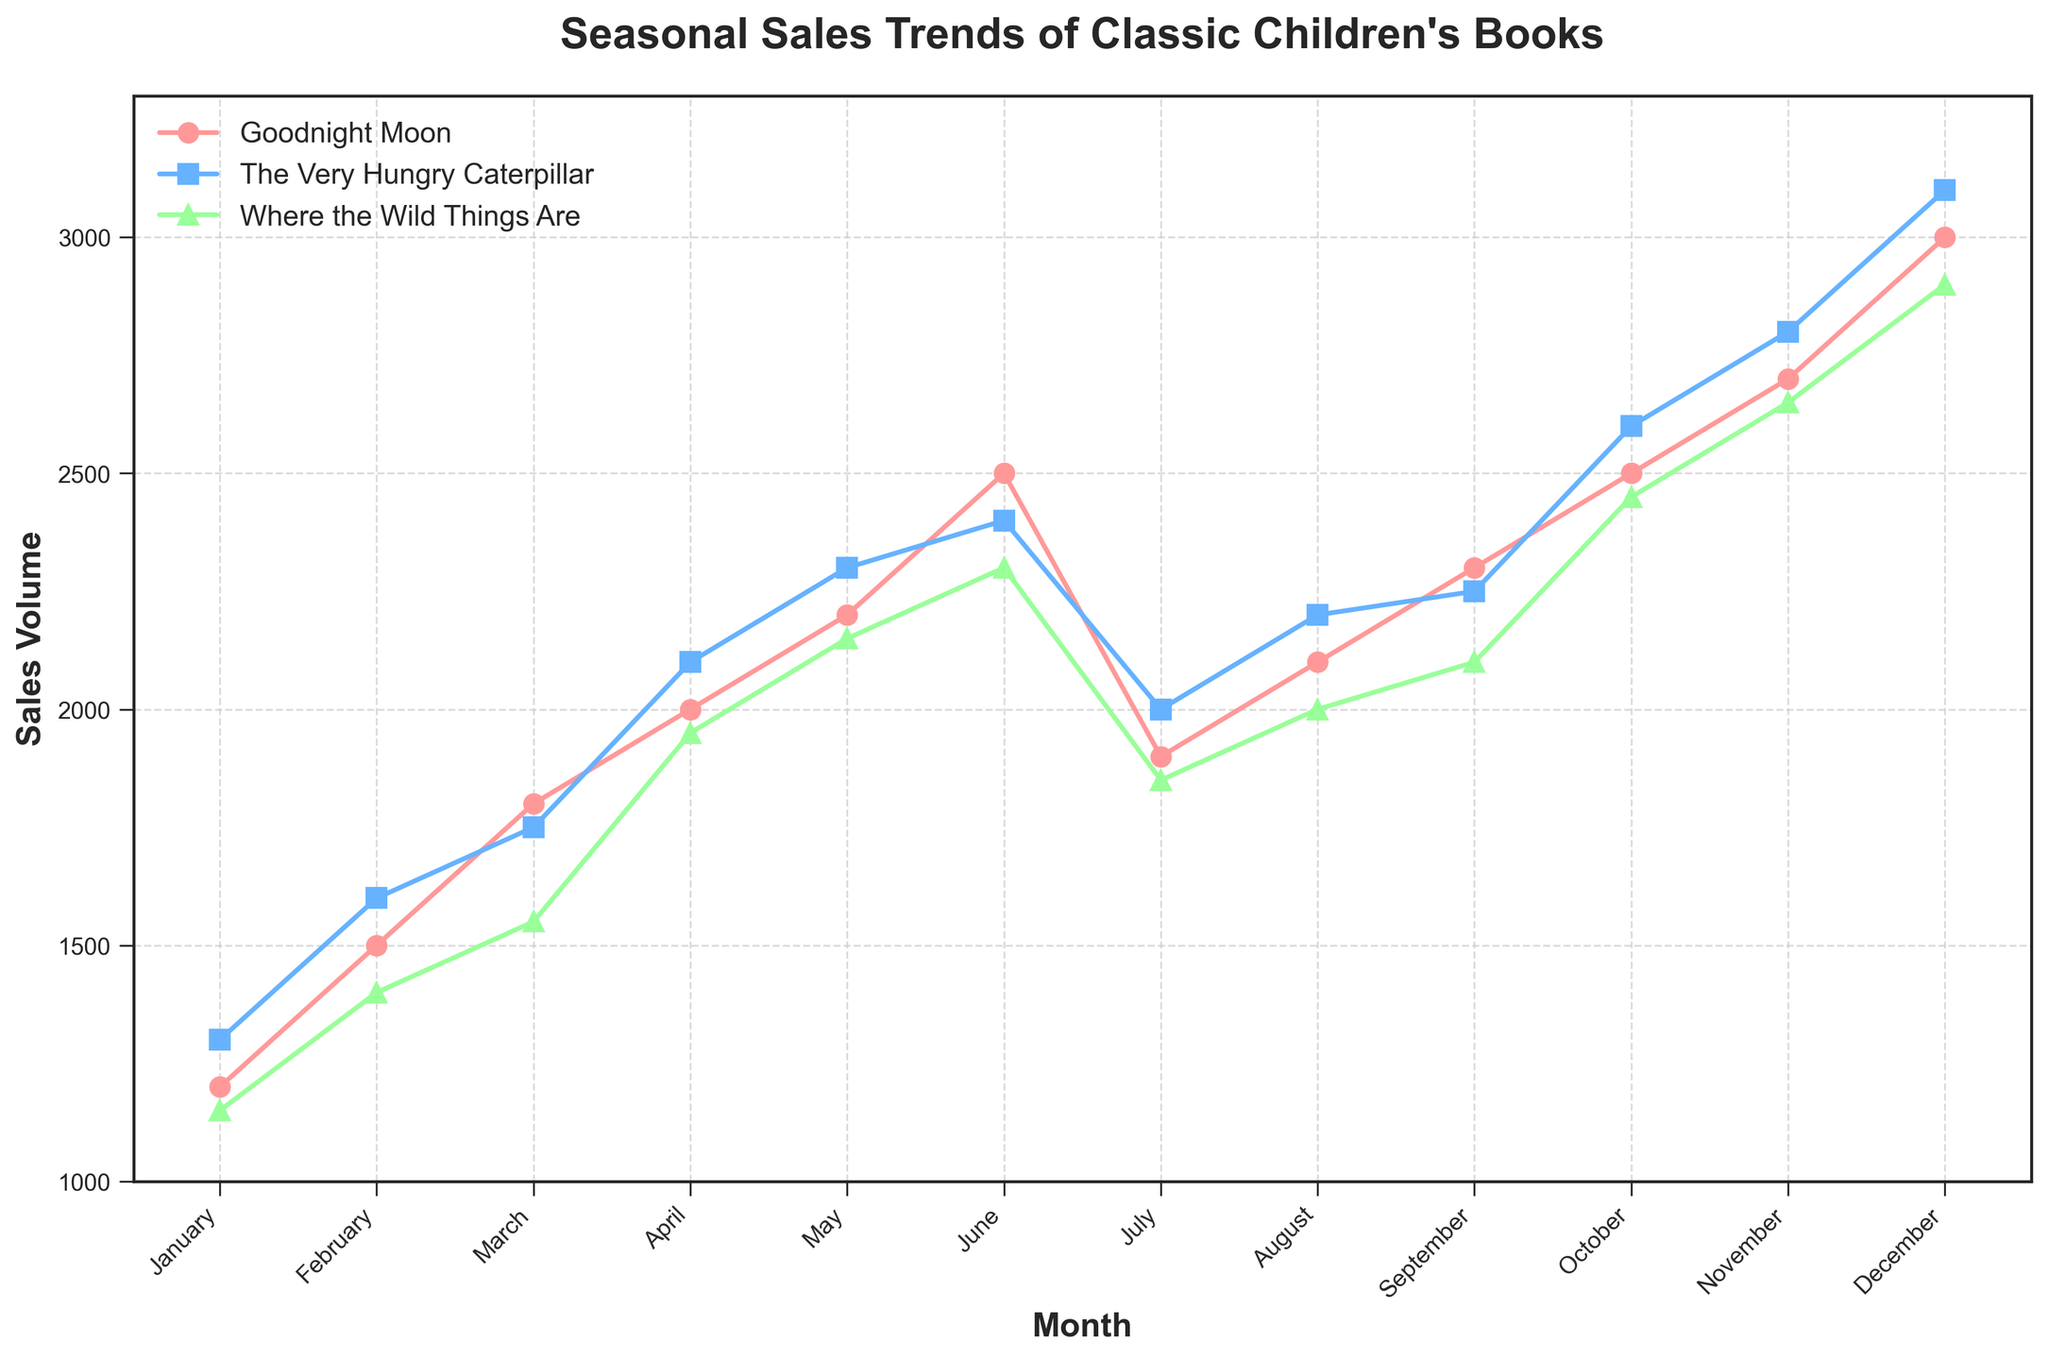What is the title of the figure? The figure title is usually displayed at the top of the plot in a larger or bold font for easy identification. Here, the title is explicitly given as 'Seasonal Sales Trends of Classic Children's Books'.
Answer: Seasonal Sales Trends of Classic Children's Books What is the highest sales volume recorded for "Goodnight Moon"? To find the highest sales volume for "Goodnight Moon," you would look for the peak point in the series of sales data labeled "Goodnight Moon." According to the data, the highest sales volume for "Goodnight Moon" occurs in December with a sales volume of 3000.
Answer: 3000 Which month has the lowest sales volume for "Where the Wild Things Are"? To determine the month with the lowest sales volume for "Where the Wild Things Are," observe the trend line for the book and identify the lowest point on the graph. From the data, the lowest sales volume of 1150 occurs in January.
Answer: January How does the sales volume of "The Very Hungry Caterpillar" in November compare to its sales volume in October? Locate the data points for "The Very Hungry Caterpillar" in October and November on the graph. In October, the sales volume is 2600, and in November, it is 2800. Comparing these values, November's sales volume is higher by 200.
Answer: November's sales volume is higher by 200 What is the average sales volume for "Goodnight Moon" over the entire year? To calculate the average sales volume for "Goodnight Moon," sum all the sales volumes for each month and then divide by the number of months (12). The total sales for each month are 1200, 1500, 1800, 2000, 2200, 2500, 1900, 2100, 2300, 2500, 2700, and 3000, which sums up to 26700. The average is 26700 / 12 = 2225.
Answer: 2225 In which month does "The Very Hungry Caterpillar" have a sales volume of 2250? Identify the month by locating where the sales volume of 2250 is plotted for "The Very Hungry Caterpillar". According to the data, this occurs in September.
Answer: September Which book has the highest overall increase in sales volume from January to December? Calculate the difference in sales volume between December and January for each book, then compare these differences. "Goodnight Moon" increases from 1200 to 3000 (an increase of 1800), "The Very Hungry Caterpillar" from 1300 to 3100 (an increase of 1800), and "Where the Wild Things Are" from 1150 to 2900 (an increase of 1750). So both "Goodnight Moon" and "The Very Hungry Caterpillar" have the highest increase of 1800.
Answer: "Goodnight Moon" and "The Very Hungry Caterpillar" During which months do all three books experience an increase in sales compared to the previous month? Analyze each book's sales pattern month-by-month to identify when all three books have an increasing trend from the previous month. The months where all three books' sales increase compared to the previous month are February, March, April, May, June, August, September, October, and November.
Answer: February, March, April, May, June, August, September, October, November 